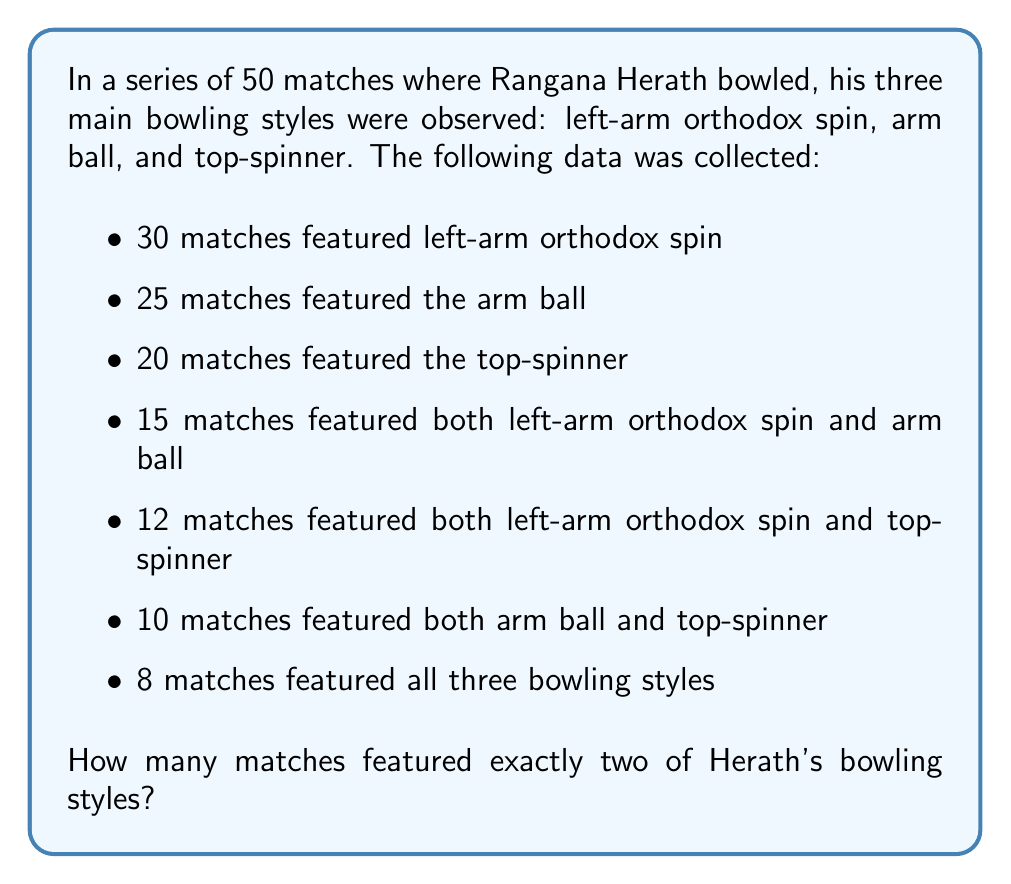What is the answer to this math problem? Let's approach this step-by-step using a Venn diagram and set theory:

1) Let's define our sets:
   A: matches with left-arm orthodox spin
   B: matches with arm ball
   C: matches with top-spinner

2) We're given:
   $n(A) = 30$, $n(B) = 25$, $n(C) = 20$
   $n(A \cap B) = 15$, $n(A \cap C) = 12$, $n(B \cap C) = 10$
   $n(A \cap B \cap C) = 8$

3) We can use the principle of inclusion-exclusion to find the total number of matches featuring at least one style:

   $n(A \cup B \cup C) = n(A) + n(B) + n(C) - n(A \cap B) - n(A \cap C) - n(B \cap C) + n(A \cap B \cap C)$

   $n(A \cup B \cup C) = 30 + 25 + 20 - 15 - 12 - 10 + 8 = 46$

4) Now, let's find the number of matches featuring exactly two styles:
   - Matches with A and B only: $n(A \cap B) - n(A \cap B \cap C) = 15 - 8 = 7$
   - Matches with A and C only: $n(A \cap C) - n(A \cap B \cap C) = 12 - 8 = 4$
   - Matches with B and C only: $n(B \cap C) - n(A \cap B \cap C) = 10 - 8 = 2$

5) The total number of matches featuring exactly two styles is the sum of these:
   $7 + 4 + 2 = 13$
Answer: 13 matches featured exactly two of Herath's bowling styles. 